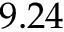Convert formula to latex. <formula><loc_0><loc_0><loc_500><loc_500>9 . 2 4</formula> 